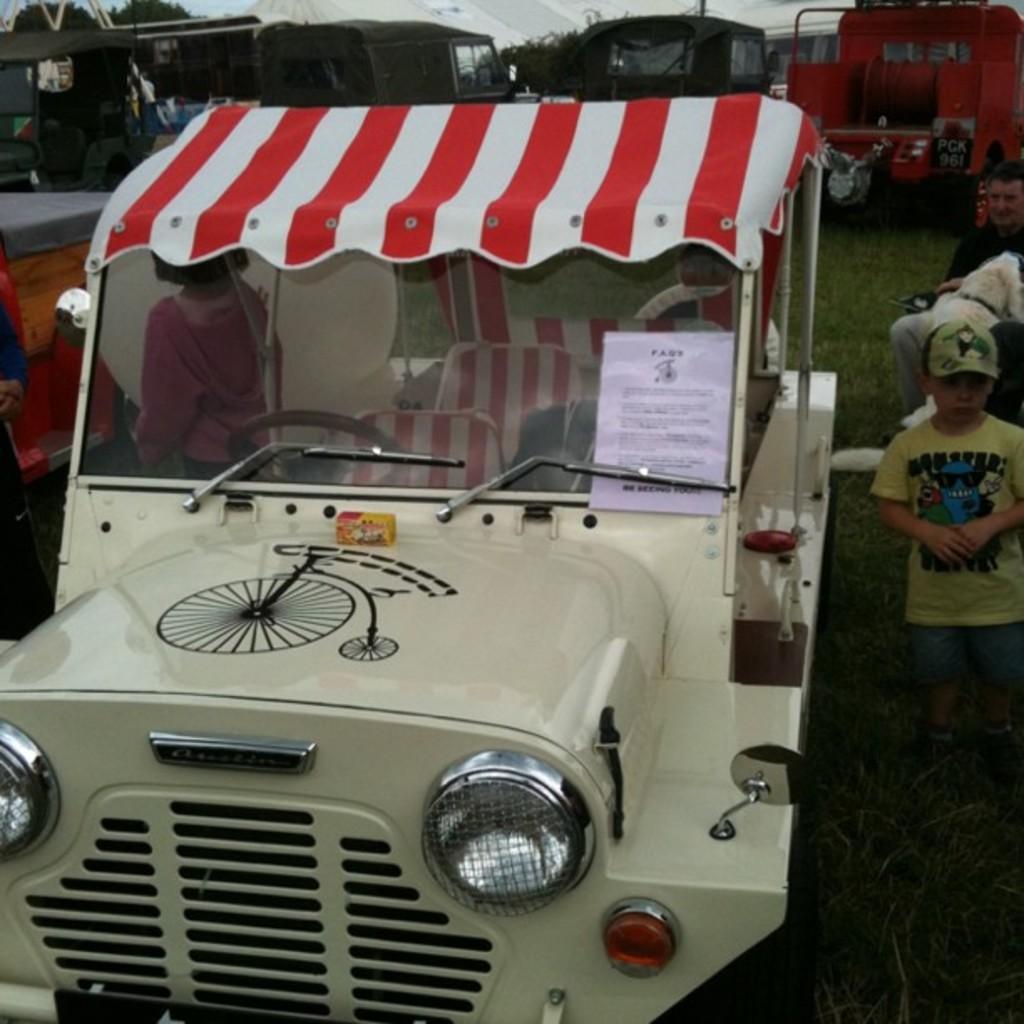Could you give a brief overview of what you see in this image? In this image we can see group of vehicles parked on the ground. In the foreground we can see a vehicle with a paper and text on it. On the right side of the image we can see group of people and a dog. On the left side of the image we can see some persons standing. In the background, we can see a grass, group of trees and the sky. 